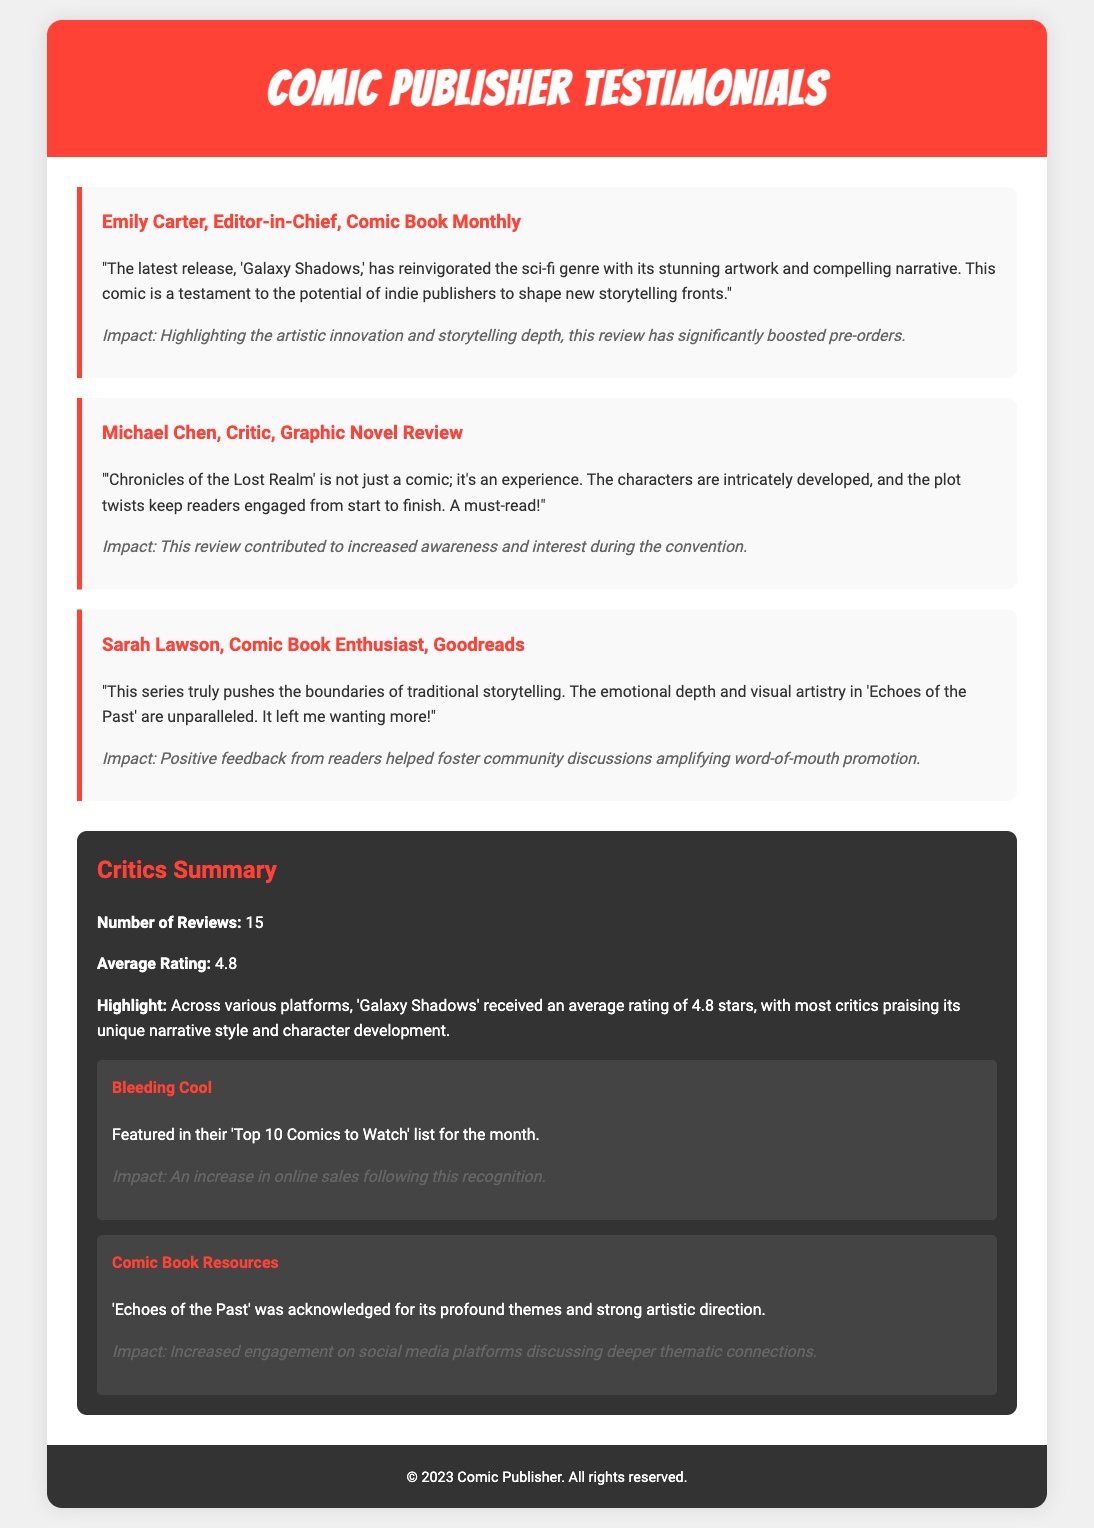What is the title of the latest release? The title of the latest release is 'Galaxy Shadows,' as mentioned in the testimonial by Emily Carter.
Answer: 'Galaxy Shadows' Who is the Editor-in-Chief providing a testimonial? Emily Carter is identified as the Editor-in-Chief, offering her insights on the comic.
Answer: Emily Carter What is the average rating from reviews? The average rating of the comics is indicated as 4.8 through the critics summary.
Answer: 4.8 How many reviews were there in total? The total number of reviews mentioned in the document is 15, as summarized in the critics section.
Answer: 15 Which comic is noted for pushing the boundaries of traditional storytelling? 'Echoes of the Past' is recognized for its innovative storytelling according to Sarah Lawson's testimonial.
Answer: 'Echoes of the Past' What notable source featured 'Galaxy Shadows' in their list? 'Bleeding Cool' is highlighted for featuring 'Galaxy Shadows' in their 'Top 10 Comics to Watch' list.
Answer: Bleeding Cool What impact did Sarah Lawson's feedback have? Her positive feedback helped foster community discussions which amplified word-of-mouth promotion.
Answer: Word-of-mouth promotion Which comic was acknowledged for its profound themes? 'Echoes of the Past' was acknowledged for its profound themes by Comic Book Resources.
Answer: 'Echoes of the Past' 